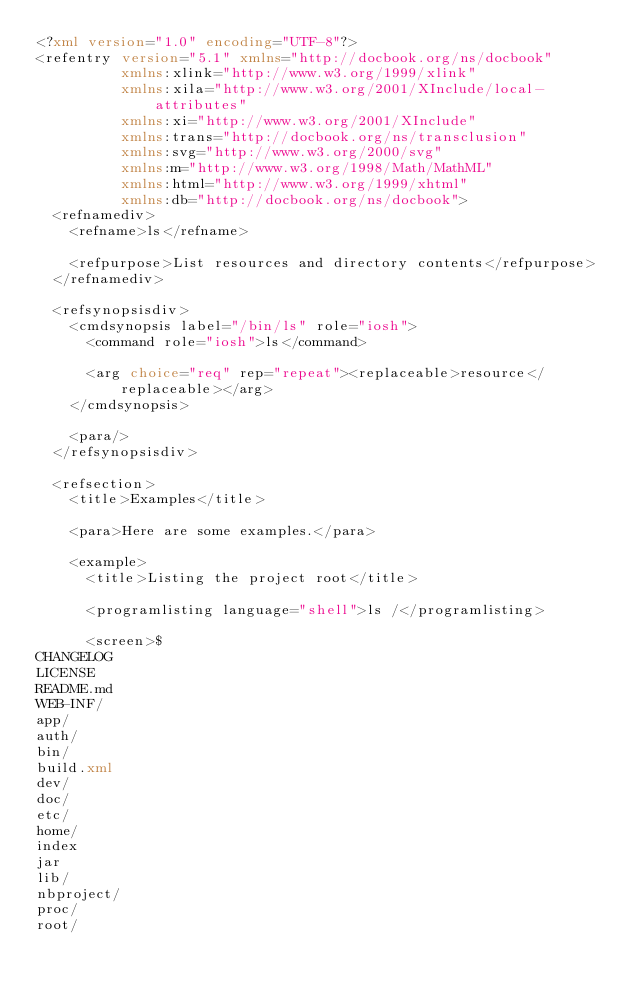Convert code to text. <code><loc_0><loc_0><loc_500><loc_500><_XML_><?xml version="1.0" encoding="UTF-8"?>
<refentry version="5.1" xmlns="http://docbook.org/ns/docbook"
          xmlns:xlink="http://www.w3.org/1999/xlink"
          xmlns:xila="http://www.w3.org/2001/XInclude/local-attributes"
          xmlns:xi="http://www.w3.org/2001/XInclude"
          xmlns:trans="http://docbook.org/ns/transclusion"
          xmlns:svg="http://www.w3.org/2000/svg"
          xmlns:m="http://www.w3.org/1998/Math/MathML"
          xmlns:html="http://www.w3.org/1999/xhtml"
          xmlns:db="http://docbook.org/ns/docbook">
  <refnamediv>
    <refname>ls</refname>

    <refpurpose>List resources and directory contents</refpurpose>
  </refnamediv>

  <refsynopsisdiv>
    <cmdsynopsis label="/bin/ls" role="iosh">
      <command role="iosh">ls</command>

      <arg choice="req" rep="repeat"><replaceable>resource</replaceable></arg>
    </cmdsynopsis>

    <para/>
  </refsynopsisdiv>

  <refsection>
    <title>Examples</title>

    <para>Here are some examples.</para>

    <example>
      <title>Listing the project root</title>

      <programlisting language="shell">ls /</programlisting>

      <screen>$
CHANGELOG
LICENSE
README.md
WEB-INF/
app/
auth/
bin/
build.xml
dev/
doc/
etc/
home/
index
jar
lib/
nbproject/
proc/
root/</code> 